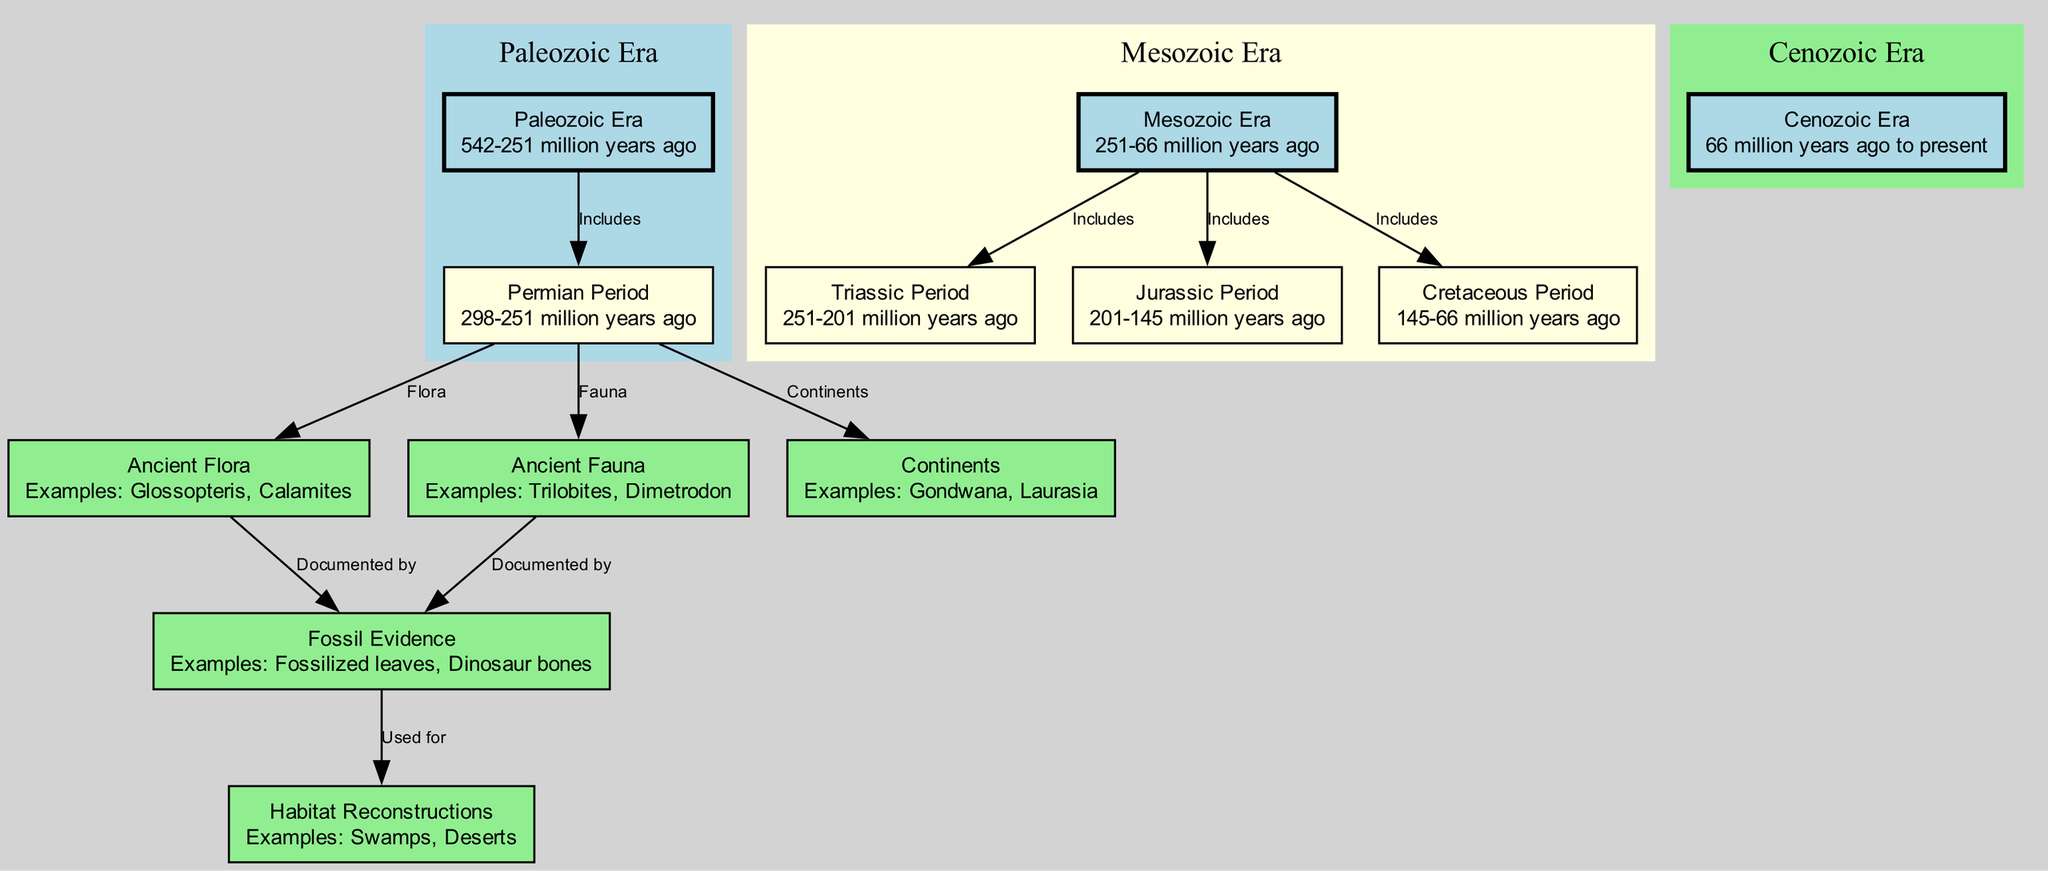What is the time range of the Paleozoic Era? The diagram indicates the Paleozoic Era spans from 542 to 251 million years ago, which is mentioned in the details of the node labeled "Paleozoic Era."
Answer: 542-251 million years ago Which ancient fauna is documented by fossil evidence from the Permian Period? The diagram shows that the fauna of the Permian Period includes examples like Trilobites, which is listed under the connection between "Permian Period" and "Ancient Fauna."
Answer: Trilobites How many periods are included in the Mesozoic Era? The diagram lists three periods under the Mesozoic Era: Triassic, Jurassic, and Cretaceous, as stated in the edges from the "Mesozoic Era" node.
Answer: Three What type of ancient flora is represented in the Permian Period? The Permian Period is connected to the "Ancient Flora" node, which provides examples of ancient plants such as Glossopteris, indicating that this type of flora existed during the period.
Answer: Glossopteris Which continents were dominant according to this diagram? The diagram shows that the continents, specifically Gondwana and Laurasia, are linked to various periods and eras, indicated in the connections from the "Continents" node.
Answer: Gondwana, Laurasia What kind of habitats are reconstructed from fossil evidence according to the diagram? The diagram indicates that habitats like swamps and deserts are examples of ecological settings reconstructed from fossil evidence, mentioned in the connection labeled "Used for" from "Fossil Evidence" to "Habitat Reconstructions."
Answer: Swamps, Deserts Which era follows the Mesozoic Era? The diagram shows that the Cenozoic Era follows the Mesozoic Era, as indicated by the directed connection from the "Mesozoic Era" node to the "Cenozoic Era" node.
Answer: Cenozoic Era What is an example of fossil evidence related to ancient fauna? The diagram links fossil evidence to ancient fauna and provides an example, which is "Dinosaur bones," showing documentation of fauna from different periods.
Answer: Dinosaur bones How is the diversity of ancient flora represented in this diagram? The diagram represents ancient flora by connecting specific examples like Glossopteris and Calamites, illustrating diverse plant life across different periods, specifically under the "Flora" label connected to the Permian Period.
Answer: Glossopteris, Calamites 